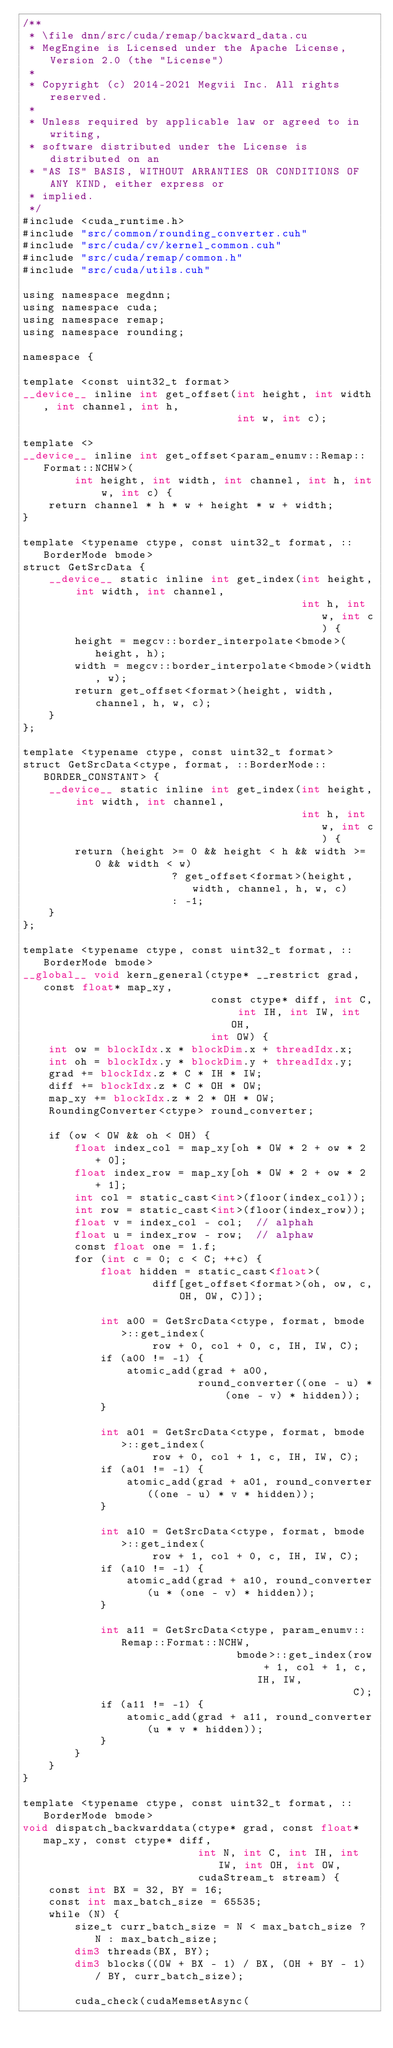<code> <loc_0><loc_0><loc_500><loc_500><_Cuda_>/**
 * \file dnn/src/cuda/remap/backward_data.cu
 * MegEngine is Licensed under the Apache License, Version 2.0 (the "License")
 *
 * Copyright (c) 2014-2021 Megvii Inc. All rights reserved.
 *
 * Unless required by applicable law or agreed to in writing,
 * software distributed under the License is distributed on an
 * "AS IS" BASIS, WITHOUT ARRANTIES OR CONDITIONS OF ANY KIND, either express or
 * implied.
 */
#include <cuda_runtime.h>
#include "src/common/rounding_converter.cuh"
#include "src/cuda/cv/kernel_common.cuh"
#include "src/cuda/remap/common.h"
#include "src/cuda/utils.cuh"

using namespace megdnn;
using namespace cuda;
using namespace remap;
using namespace rounding;

namespace {

template <const uint32_t format>
__device__ inline int get_offset(int height, int width, int channel, int h,
                                 int w, int c);

template <>
__device__ inline int get_offset<param_enumv::Remap::Format::NCHW>(
        int height, int width, int channel, int h, int w, int c) {
    return channel * h * w + height * w + width;
}

template <typename ctype, const uint32_t format, ::BorderMode bmode>
struct GetSrcData {
    __device__ static inline int get_index(int height, int width, int channel,
                                           int h, int w, int c) {
        height = megcv::border_interpolate<bmode>(height, h);
        width = megcv::border_interpolate<bmode>(width, w);
        return get_offset<format>(height, width, channel, h, w, c);
    }
};

template <typename ctype, const uint32_t format>
struct GetSrcData<ctype, format, ::BorderMode::BORDER_CONSTANT> {
    __device__ static inline int get_index(int height, int width, int channel,
                                           int h, int w, int c) {
        return (height >= 0 && height < h && width >= 0 && width < w)
                       ? get_offset<format>(height, width, channel, h, w, c)
                       : -1;
    }
};

template <typename ctype, const uint32_t format, ::BorderMode bmode>
__global__ void kern_general(ctype* __restrict grad, const float* map_xy,
                             const ctype* diff, int C, int IH, int IW, int OH,
                             int OW) {
    int ow = blockIdx.x * blockDim.x + threadIdx.x;
    int oh = blockIdx.y * blockDim.y + threadIdx.y;
    grad += blockIdx.z * C * IH * IW;
    diff += blockIdx.z * C * OH * OW;
    map_xy += blockIdx.z * 2 * OH * OW;
    RoundingConverter<ctype> round_converter;

    if (ow < OW && oh < OH) {
        float index_col = map_xy[oh * OW * 2 + ow * 2 + 0];
        float index_row = map_xy[oh * OW * 2 + ow * 2 + 1];
        int col = static_cast<int>(floor(index_col));
        int row = static_cast<int>(floor(index_row));
        float v = index_col - col;  // alphah
        float u = index_row - row;  // alphaw
        const float one = 1.f;
        for (int c = 0; c < C; ++c) {
            float hidden = static_cast<float>(
                    diff[get_offset<format>(oh, ow, c, OH, OW, C)]);

            int a00 = GetSrcData<ctype, format, bmode>::get_index(
                    row + 0, col + 0, c, IH, IW, C);
            if (a00 != -1) {
                atomic_add(grad + a00,
                           round_converter((one - u) * (one - v) * hidden));
            }

            int a01 = GetSrcData<ctype, format, bmode>::get_index(
                    row + 0, col + 1, c, IH, IW, C);
            if (a01 != -1) {
                atomic_add(grad + a01, round_converter((one - u) * v * hidden));
            }

            int a10 = GetSrcData<ctype, format, bmode>::get_index(
                    row + 1, col + 0, c, IH, IW, C);
            if (a10 != -1) {
                atomic_add(grad + a10, round_converter(u * (one - v) * hidden));
            }

            int a11 = GetSrcData<ctype, param_enumv::Remap::Format::NCHW,
                                 bmode>::get_index(row + 1, col + 1, c, IH, IW,
                                                   C);
            if (a11 != -1) {
                atomic_add(grad + a11, round_converter(u * v * hidden));
            }
        }
    }
}

template <typename ctype, const uint32_t format, ::BorderMode bmode>
void dispatch_backwarddata(ctype* grad, const float* map_xy, const ctype* diff,
                           int N, int C, int IH, int IW, int OH, int OW,
                           cudaStream_t stream) {
    const int BX = 32, BY = 16;
    const int max_batch_size = 65535;
    while (N) {
        size_t curr_batch_size = N < max_batch_size ? N : max_batch_size;
        dim3 threads(BX, BY);
        dim3 blocks((OW + BX - 1) / BX, (OH + BY - 1) / BY, curr_batch_size);

        cuda_check(cudaMemsetAsync(</code> 